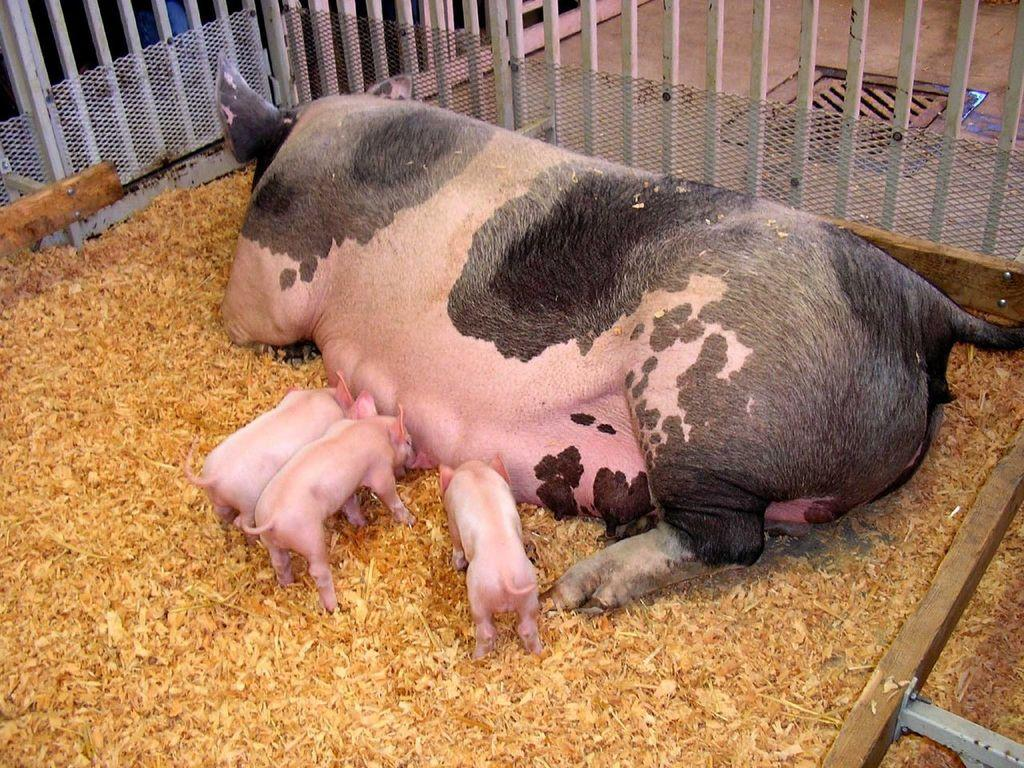What types of living organisms can be seen in the image? There are animals in the image. What can be found on the floor in the image? There are dry objects on the floor in the image. What is visible beneath the animals and objects in the image? The ground is visible in the image. What structures are present in the image? There are poles in the image. Where are additional objects located in the image? There are objects in the bottom right side of the image. What type of sheet is covering the animals in the image? There is no sheet present in the image; the animals are not covered. 